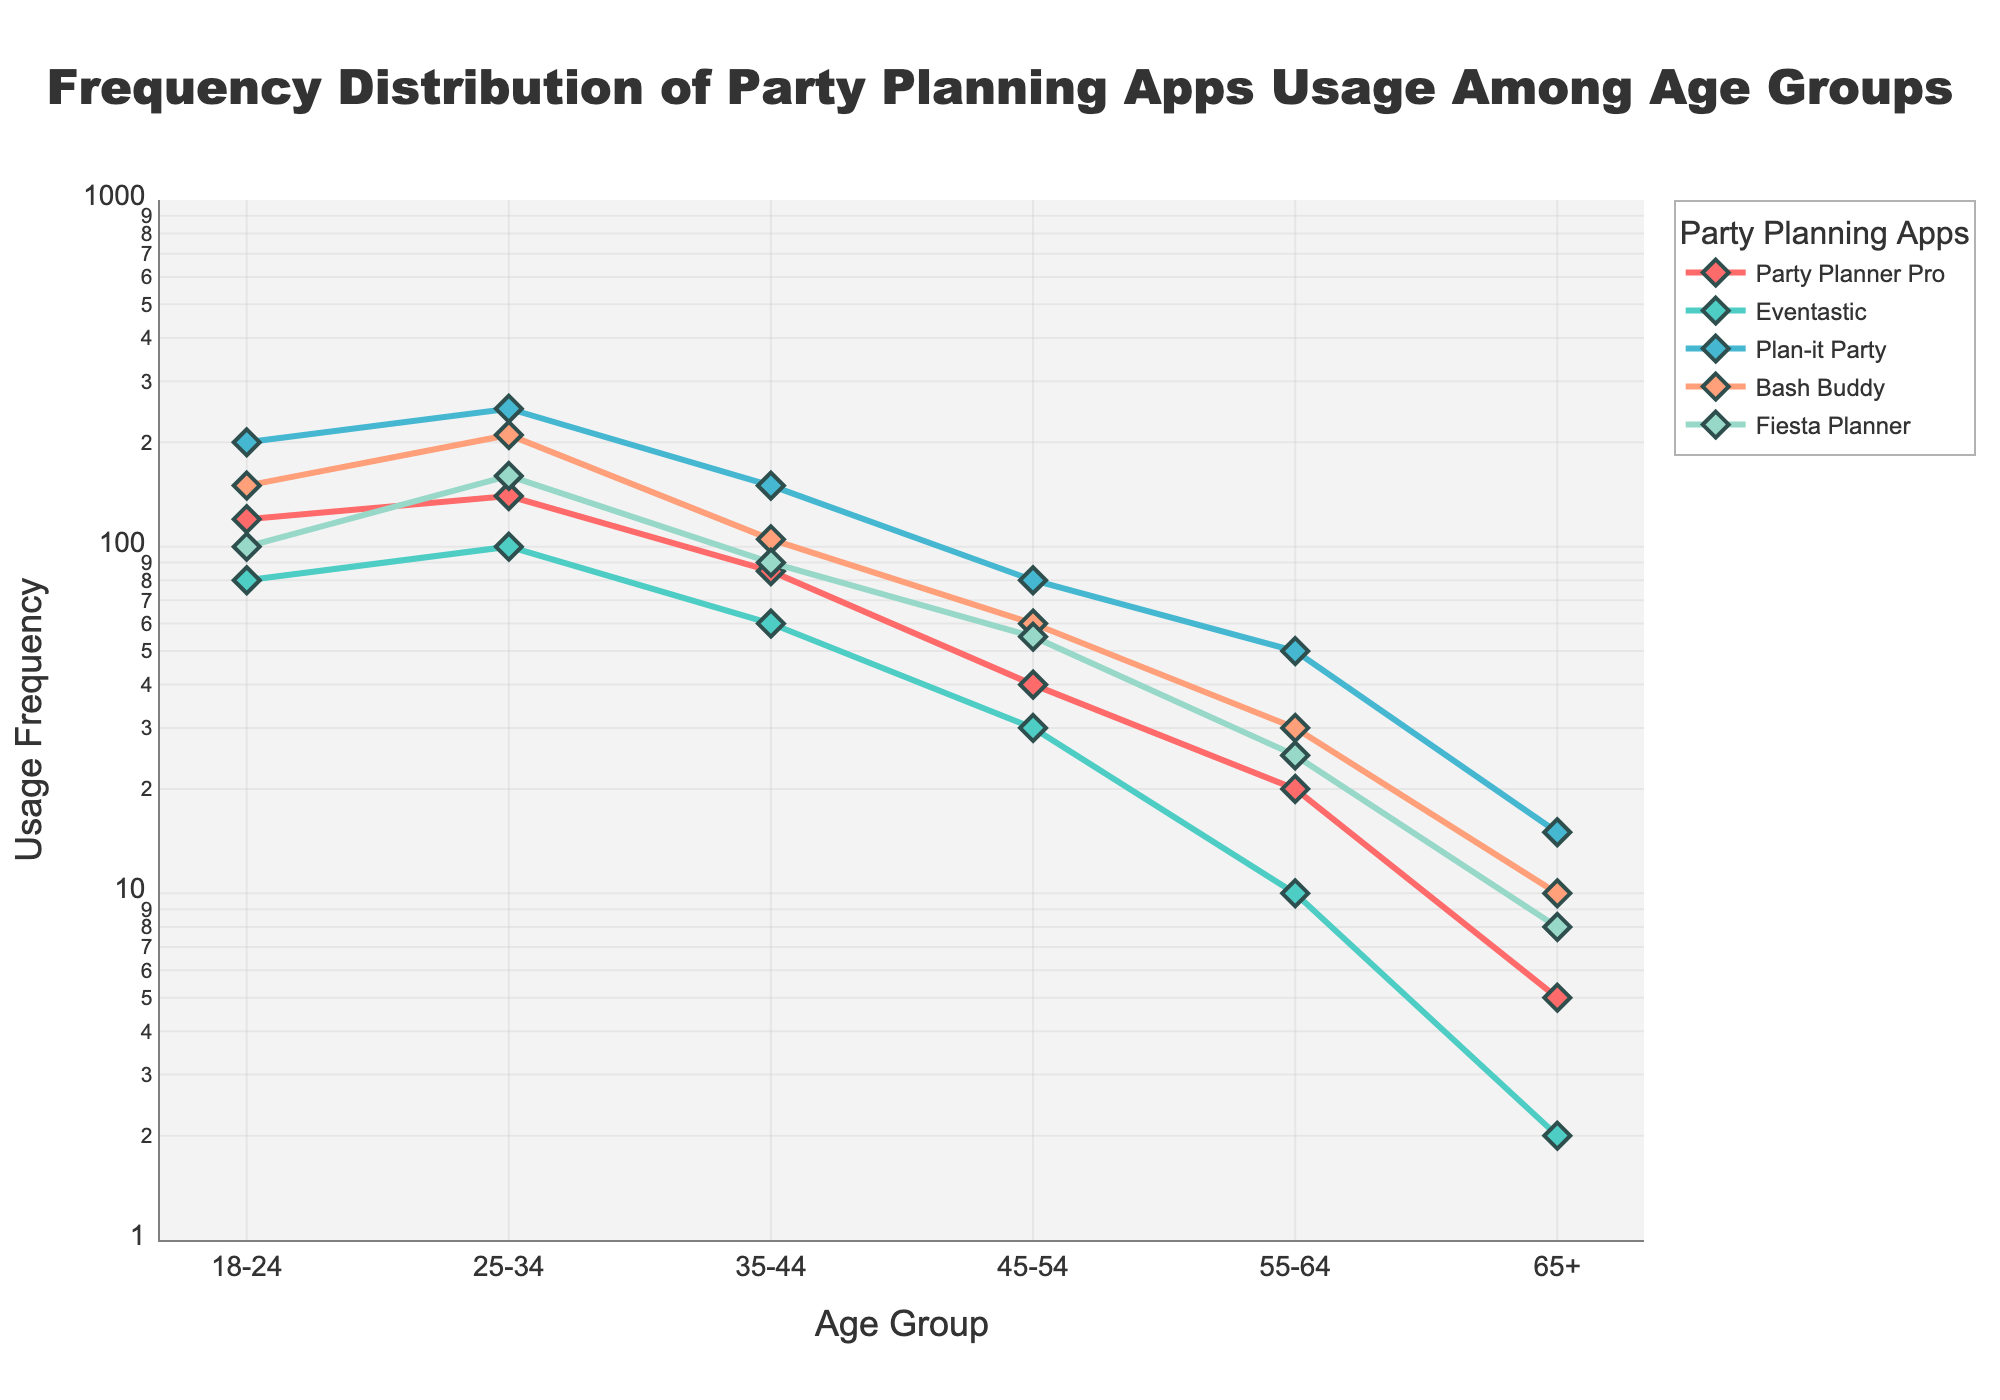What's the title of the figure? The title of the figure is located at the top and centered. It reads, 'Frequency Distribution of Party Planning Apps Usage Among Age Groups'.
Answer: Frequency Distribution of Party Planning Apps Usage Among Age Groups Which age group has the highest usage for 'Plan-it Party'? In the plot, you can see that the 'Plan-it Party' line (teal color) has its highest point at the 25-34 age group.
Answer: 25-34 Compare the usage of 'Party Planner Pro' and 'Fiesta Planner' for the 35-44 age group. Which one is higher? In the plot, for the 35-44 age group, the purple line (Party Planner Pro) is at 85, while the green line (Fiesta Planner) is at 90.
Answer: Fiesta Planner How many age groups are plotted in the figure? By counting the distinct categories on the x-axis, there are 6 age groups listed: 18-24, 25-34, 35-44, 45-54, 55-64, and 65+.
Answer: 6 What is the approximate usage frequency of 'Eventastic' for the 55-64 age group? The plot shows that the blue line (Eventastic) for the 55-64 age group is approximately 10 based on the y-axis values.
Answer: 10 What's the difference in usage between 'Bash Buddy' and 'Party Planner Pro' for the 18-24 age group? From the plot, 'Bash Buddy' (orange line) has a usage of 150 and 'Party Planner Pro' (red line) has a usage of 120 for the 18-24 age group. The difference is 150 - 120 = 30.
Answer: 30 What trend do you observe in the usage of 'Fiesta Planner' as the age groups progress from 18-24 to 65+? The plot indicates that the green line (Fiesta Planner) shows a decreasing trend as the age groups get older.
Answer: Decreasing Which app shows the steepest decline in usage as age increases from the 18-24 group to the 65+ group? The line for 'Plan-it Party' (teal color) declines most steeply compared to other apps from 200 at 18-24 to 15 at 65+.
Answer: Plan-it Party Explain why the y-axis uses a log scale in this figure. A log scale is used for the y-axis to better visualize the wide range of usage values, accommodating both high and low numbers on the same plot. This ensures that even low frequencies are visible and comparable.
Answer: To visualize a wide range of values Which app experiences a drastic drop in usage from the 25-34 age group to the 35-44 age group, and by how much? 'Plan-it Party' (teal line) drops from 250 to 150, resulting in a drastic drop of 250 - 150 = 100.
Answer: Plan-it Party, 100 